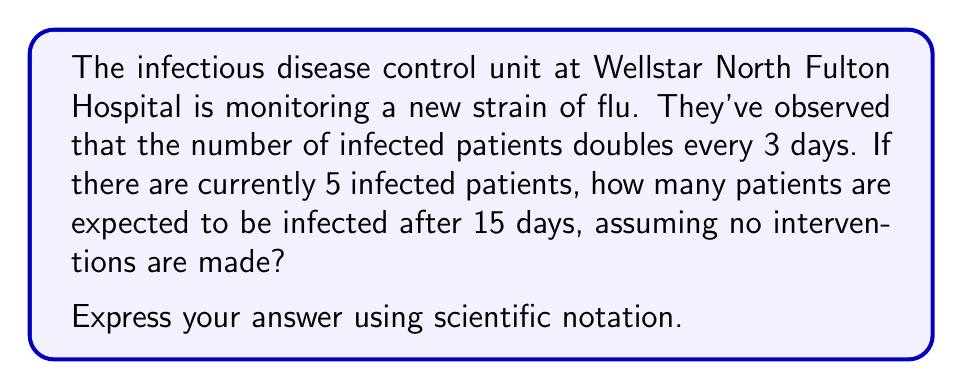Can you answer this question? Let's approach this problem step-by-step using an exponential growth model:

1) The basic form of exponential growth is:
   $$ A(t) = A_0 \cdot b^t $$
   Where:
   $A(t)$ is the amount after time $t$
   $A_0$ is the initial amount
   $b$ is the growth factor
   $t$ is the time

2) We know:
   - Initial number of patients, $A_0 = 5$
   - The number doubles every 3 days, so in 3 days it's multiplied by 2
   - We want to know the number after 15 days

3) First, let's find $b$:
   $$ 2 = b^3 $$
   $$ b = \sqrt[3]{2} \approx 1.2599 $$

4) Now, we need to adjust our equation for the 15-day period:
   $$ A(15) = 5 \cdot (1.2599)^5 $$
   
   Note that we use 5 as the exponent because 15 days ÷ 3 days = 5 doubling periods

5) Let's calculate:
   $$ A(15) = 5 \cdot (1.2599)^5 $$
   $$ = 5 \cdot 3.9837 $$
   $$ = 19.9185 $$

6) Rounding to the nearest whole number (as we can't have fractional patients):
   $$ A(15) \approx 20 $$

7) In scientific notation:
   $$ A(15) \approx 2.0 \times 10^1 $$
Answer: $2.0 \times 10^1$ patients 